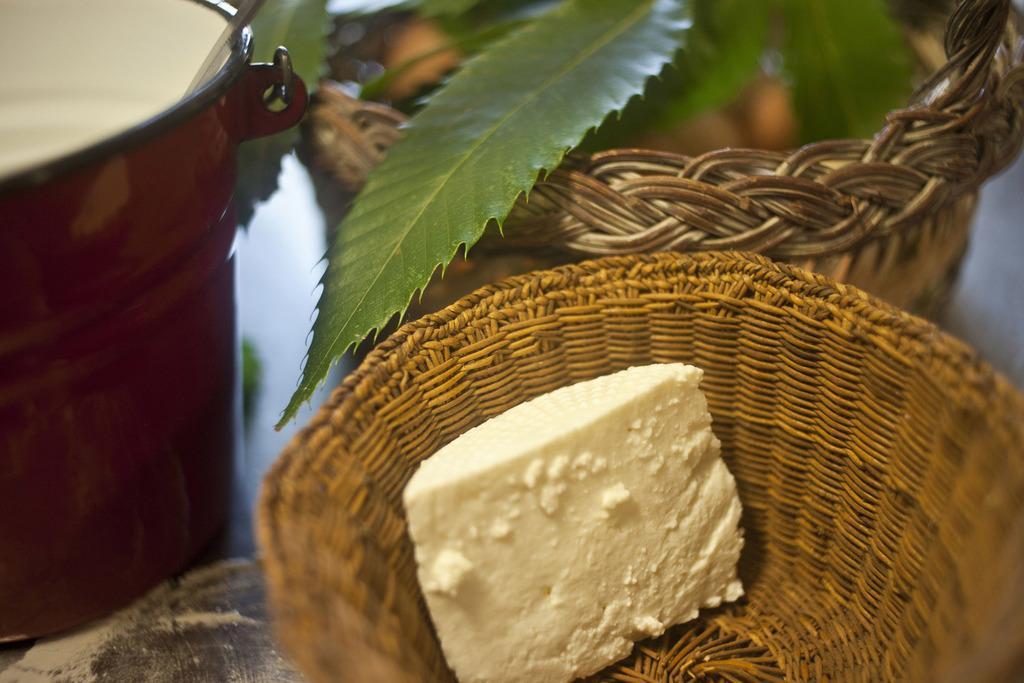Could you give a brief overview of what you see in this image? In the image we can see there is a sweet kept in a basket and beside there is a bucket and a basket. 